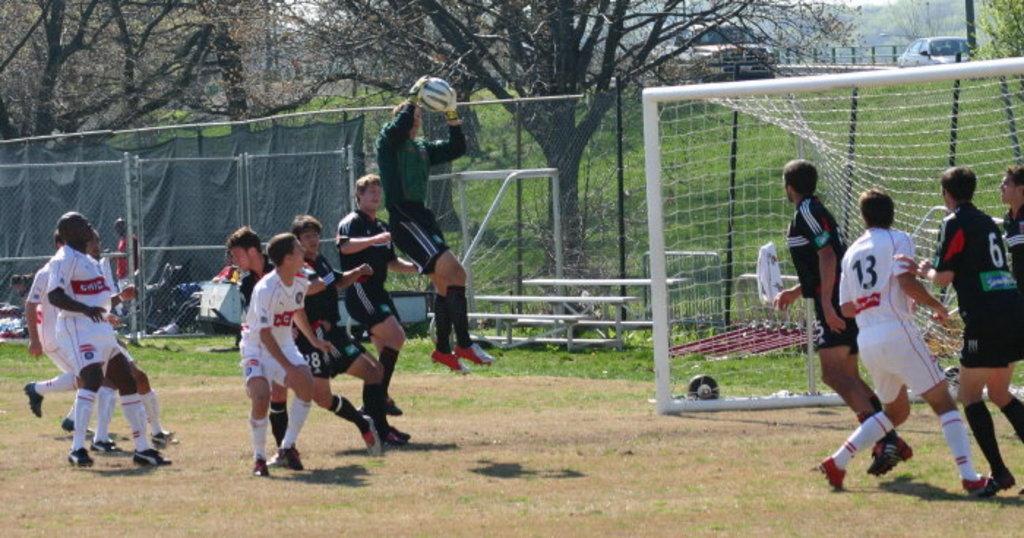How would you summarize this image in a sentence or two? There are many players on the football court. A man with green t-shirt is holding the ball and he is in the air. And some are wearing white t-shirt. At the back of them there is a mesh. In the background there are some trees. In the right side there is a court. And there are some men standing and some are running. 